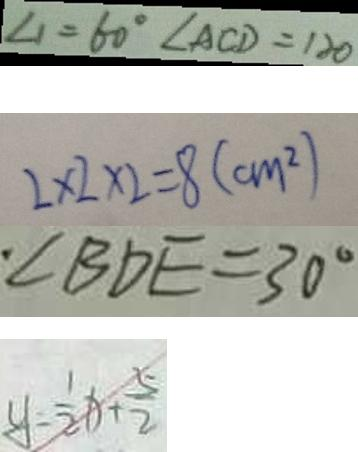<formula> <loc_0><loc_0><loc_500><loc_500>\angle 1 = 6 0 ^ { \circ } \angle A C D = 1 2 0 
 2 \times 2 \times 2 = 8 ( c m ^ { 2 } ) 
 \angle B D E = 3 0 ^ { \circ } 
 y = \frac { 1 } { 2 } x + \frac { 5 } { 2 }</formula> 